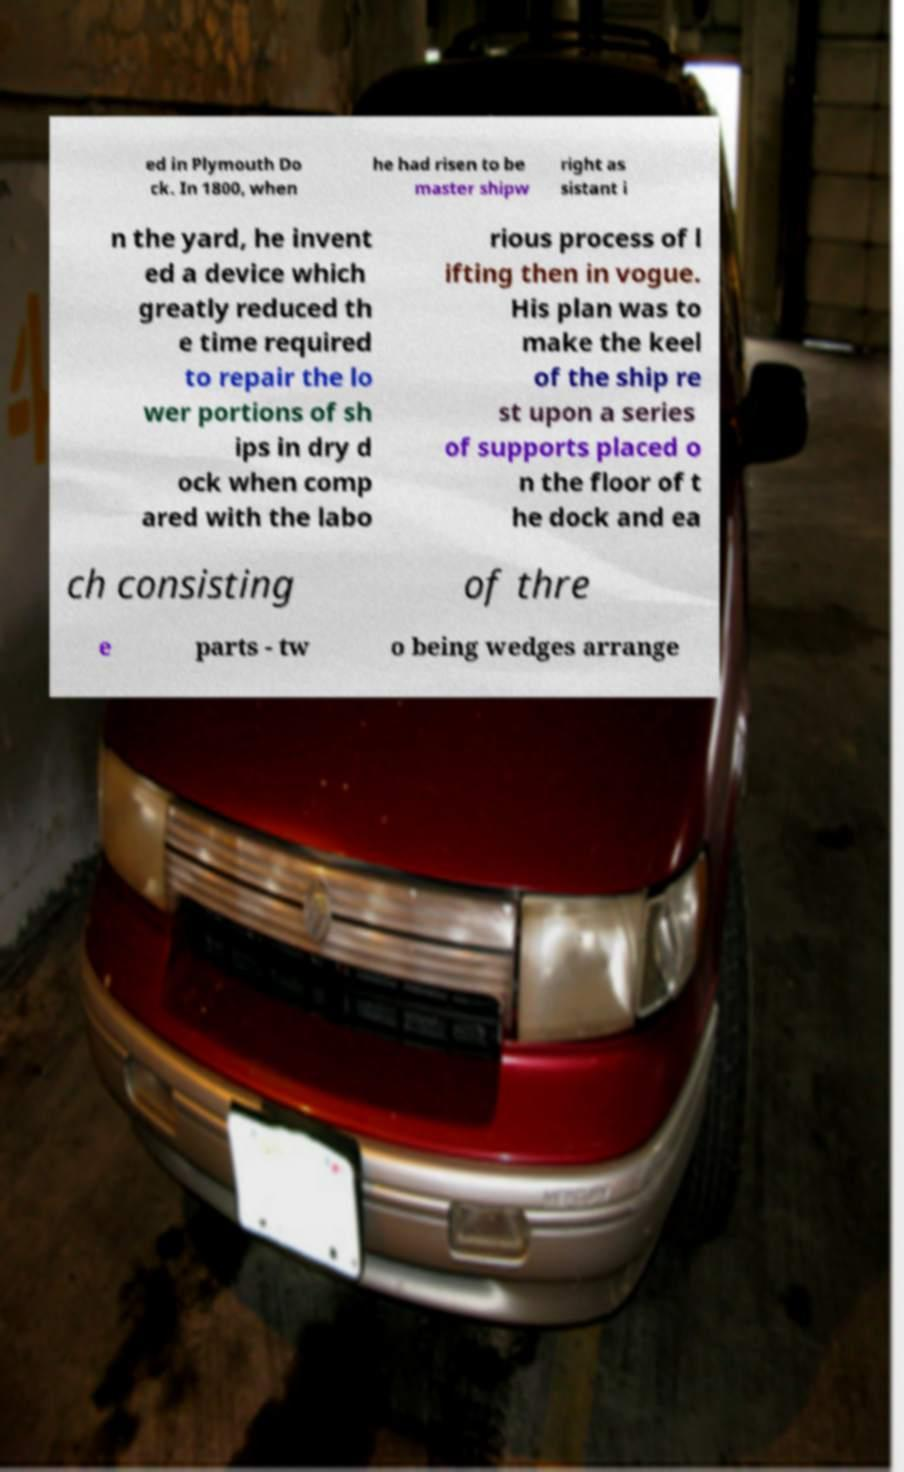For documentation purposes, I need the text within this image transcribed. Could you provide that? ed in Plymouth Do ck. In 1800, when he had risen to be master shipw right as sistant i n the yard, he invent ed a device which greatly reduced th e time required to repair the lo wer portions of sh ips in dry d ock when comp ared with the labo rious process of l ifting then in vogue. His plan was to make the keel of the ship re st upon a series of supports placed o n the floor of t he dock and ea ch consisting of thre e parts - tw o being wedges arrange 